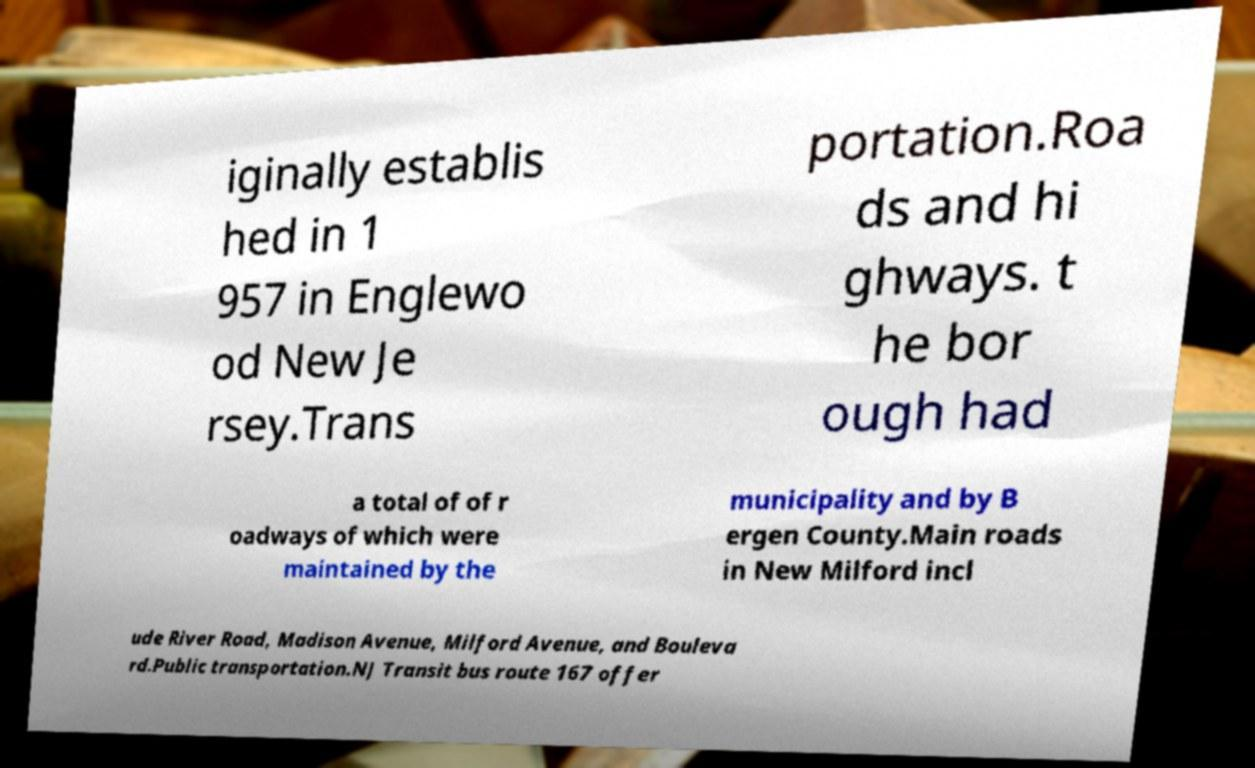Can you accurately transcribe the text from the provided image for me? iginally establis hed in 1 957 in Englewo od New Je rsey.Trans portation.Roa ds and hi ghways. t he bor ough had a total of of r oadways of which were maintained by the municipality and by B ergen County.Main roads in New Milford incl ude River Road, Madison Avenue, Milford Avenue, and Bouleva rd.Public transportation.NJ Transit bus route 167 offer 